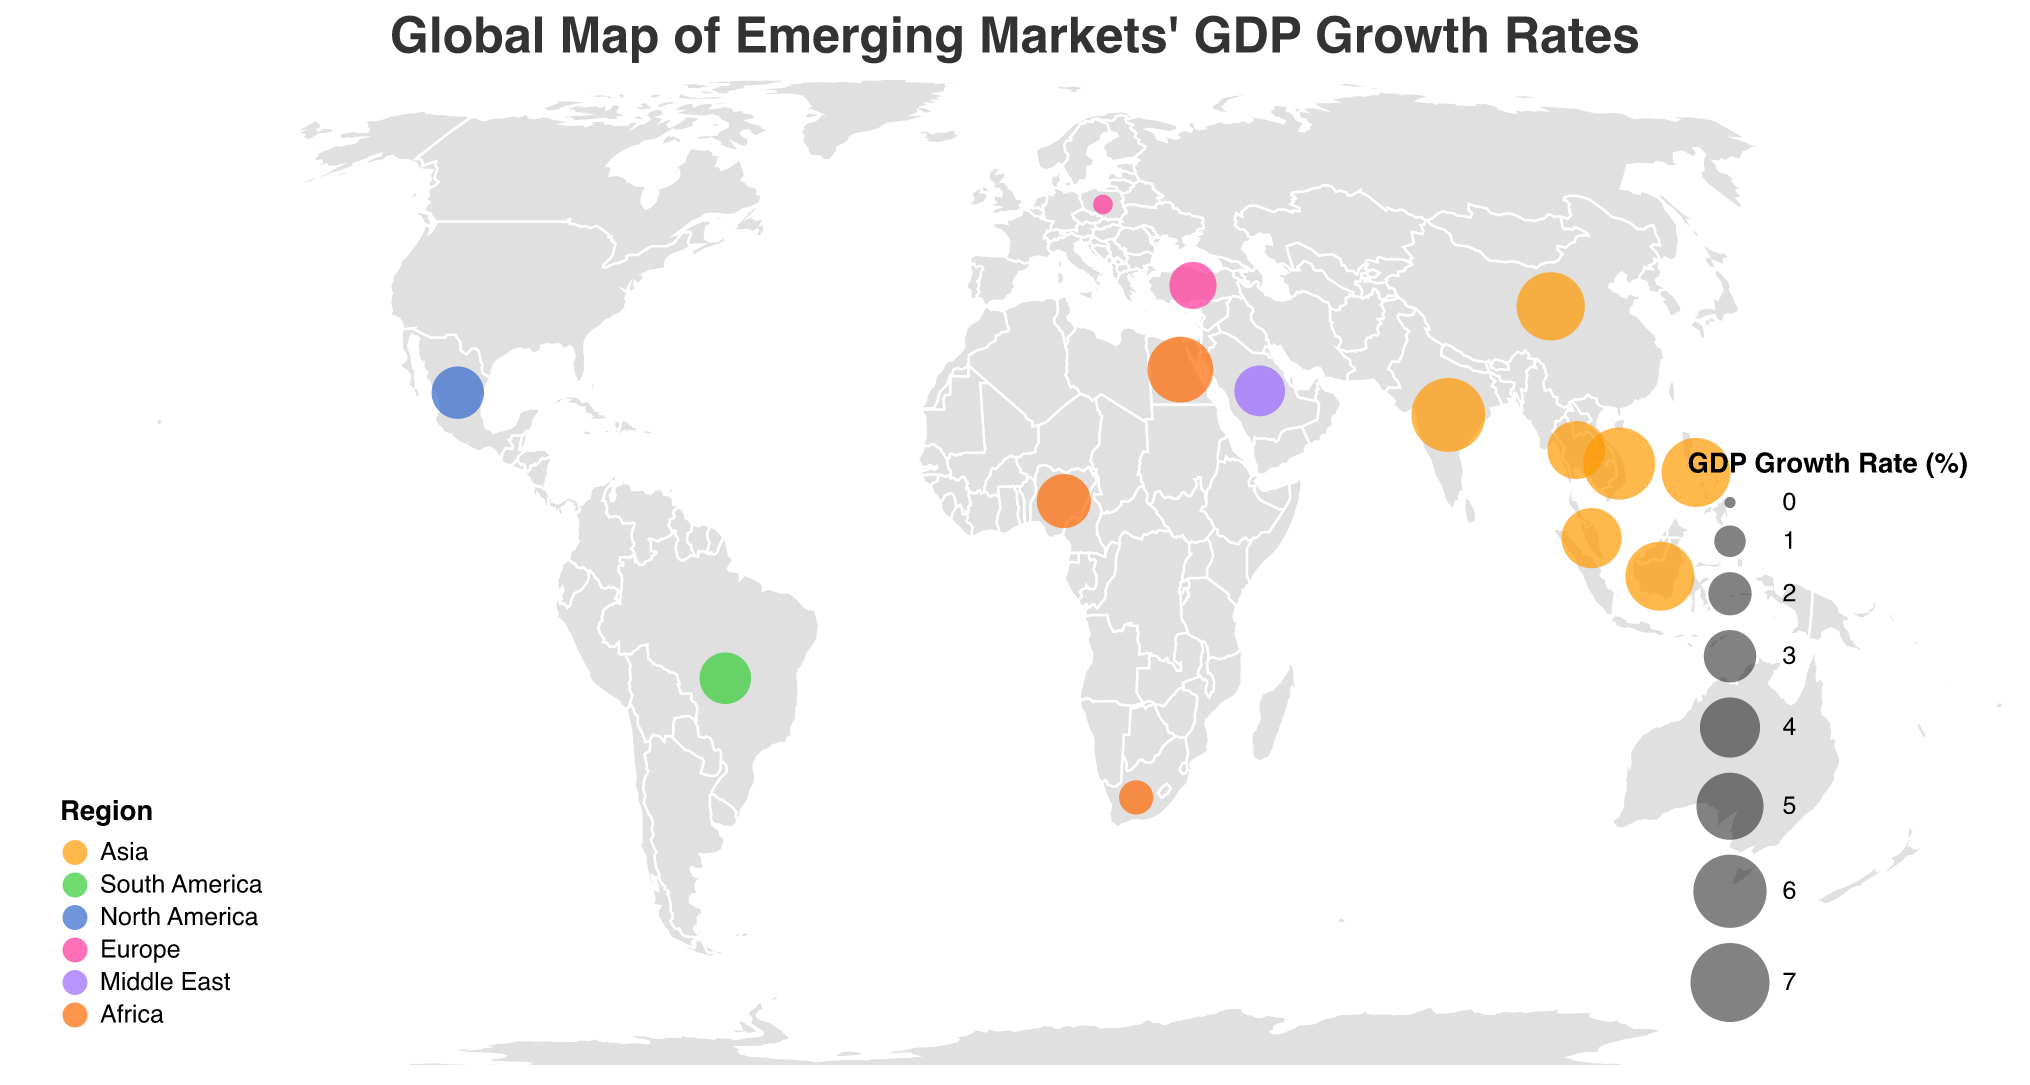How many data points are represented on the figure? There is one data point for each country listed in the dataframe. Counting them, we find there are 15 countries.
Answer: 15 Which region has the highest number of countries represented in this map? The Asia region includes China, India, Indonesia, Thailand, Malaysia, Philippines, and Vietnam, totaling 7 countries, which is the highest among all regions.
Answer: Asia Which country in the figure has the highest GDP growth rate? By evaluating the GDP growth rates for each country, India has the highest GDP growth rate of 6.1%.
Answer: India What is the GDP growth rate of the country with the lowest unemployment rate? Thailand has the lowest unemployment rate of 1.5%. Looking at the dataset, Thailand's GDP growth rate is 3.7%.
Answer: 3.7% Compare the GDP growth rates of Brazil and South Africa. Which one is higher? The GDP growth rate for Brazil is 2.9%, while South Africa's GDP growth rate is 1.2%. Thus, Brazil has the higher GDP growth rate.
Answer: Brazil What is the combined GDP growth rate of Asia and Europe regions? Summing the GDP growth rates of the Asian countries (5.2, 6.1, 5.3, 3.7, 4.0, 5.3, 5.8) gives 35.4%. Adding the GDP growth rates of the European countries (2.4, 0.3) results in 2.7%. Combining these, the total GDP growth rate is 35.4% + 2.7% = 38.1%.
Answer: 38.1% Which country in the figure has the highest inflation rate, and what is it? By examining the inflation rates, Turkey has the highest inflation rate at 53.5%.
Answer: Turkey What is the difference in unemployment rates between the country with the highest GDP growth rate and the country with the lowest GDP growth rate? The country with the highest GDP growth rate is India (6.1%) with an unemployment rate of 7.1%. The country with the lowest GDP growth rate is Poland (0.3%) with an unemployment rate of 2.8%. The difference in unemployment rates is 7.1% - 2.8% = 4.3%.
Answer: 4.3% From the visual information, how can you differentiate the regions on the map? The regions are represented by different colors on the map. Asia is orange, South America is green, North America is blue, Europe is pink, Middle East is purple, and Africa is a different shade of orange.
Answer: By color Which country has the largest FDI inflow, and in which region is it located? China has the largest Foreign Direct Investment (FDI) inflow of 163,000. It is located in the Asia region.
Answer: China, Asia 